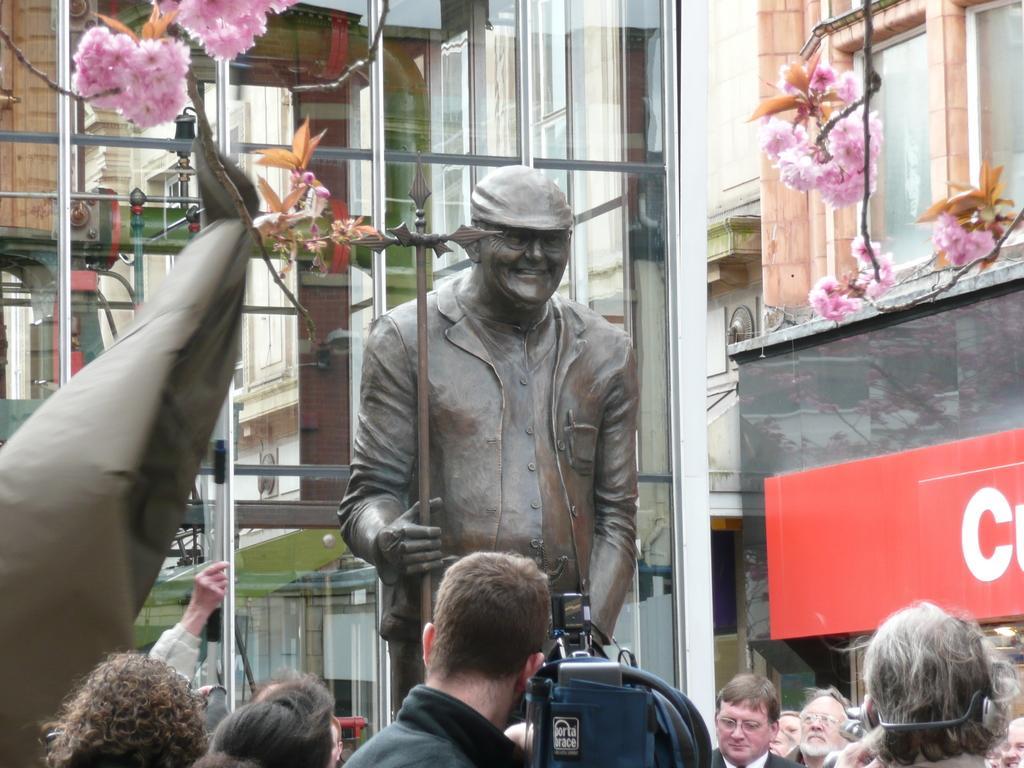How would you summarize this image in a sentence or two? In this picture we can see a group of people, flowers, statue of a person smiling and some objects and in the background we can see buildings. 